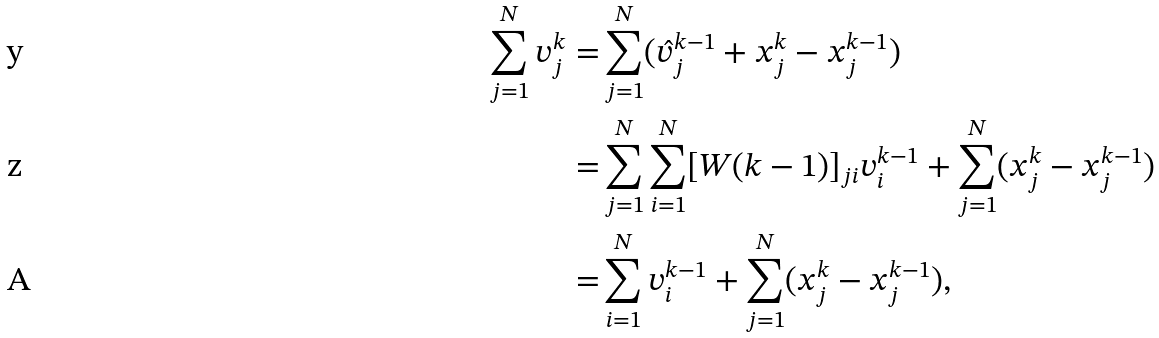Convert formula to latex. <formula><loc_0><loc_0><loc_500><loc_500>\sum _ { j = 1 } ^ { N } { v _ { j } ^ { k } } = & \sum _ { j = 1 } ^ { N } ( \hat { v } _ { j } ^ { k - 1 } + x _ { j } ^ { k } - x _ { j } ^ { k - 1 } ) \\ = & \sum _ { j = 1 } ^ { N } \sum _ { i = 1 } ^ { N } [ W ( k - 1 ) ] _ { j i } v _ { i } ^ { k - 1 } + \sum _ { j = 1 } ^ { N } ( x _ { j } ^ { k } - x _ { j } ^ { k - 1 } ) \\ = & \sum _ { i = 1 } ^ { N } v _ { i } ^ { k - 1 } + \sum _ { j = 1 } ^ { N } ( x _ { j } ^ { k } - x _ { j } ^ { k - 1 } ) ,</formula> 